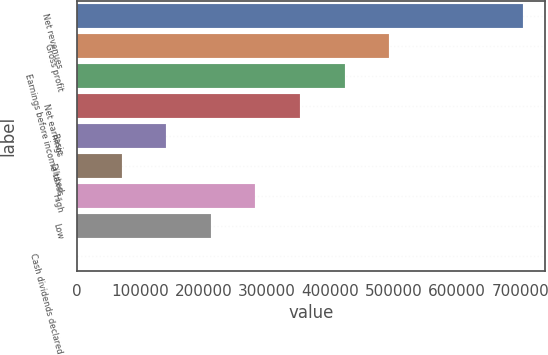Convert chart to OTSL. <chart><loc_0><loc_0><loc_500><loc_500><bar_chart><fcel>Net revenues<fcel>Gross profit<fcel>Earnings before income taxes<fcel>Net earnings<fcel>Basic<fcel>Diluted<fcel>High<fcel>Low<fcel>Cash dividends declared<nl><fcel>704220<fcel>492954<fcel>422532<fcel>352110<fcel>140844<fcel>70422.2<fcel>281688<fcel>211266<fcel>0.2<nl></chart> 